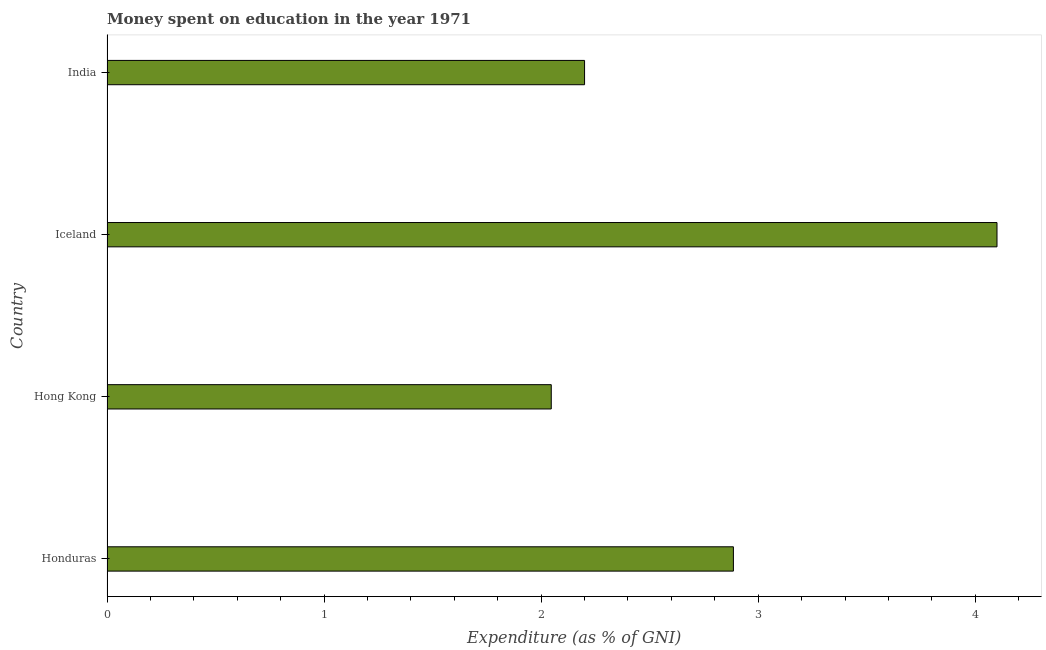What is the title of the graph?
Give a very brief answer. Money spent on education in the year 1971. What is the label or title of the X-axis?
Your answer should be very brief. Expenditure (as % of GNI). What is the label or title of the Y-axis?
Provide a succinct answer. Country. Across all countries, what is the maximum expenditure on education?
Keep it short and to the point. 4.1. Across all countries, what is the minimum expenditure on education?
Give a very brief answer. 2.05. In which country was the expenditure on education maximum?
Offer a very short reply. Iceland. In which country was the expenditure on education minimum?
Keep it short and to the point. Hong Kong. What is the sum of the expenditure on education?
Provide a succinct answer. 11.23. What is the difference between the expenditure on education in Honduras and Hong Kong?
Offer a very short reply. 0.84. What is the average expenditure on education per country?
Provide a succinct answer. 2.81. What is the median expenditure on education?
Provide a short and direct response. 2.54. What is the ratio of the expenditure on education in Hong Kong to that in India?
Offer a very short reply. 0.93. Is the expenditure on education in Hong Kong less than that in India?
Your answer should be very brief. Yes. Is the difference between the expenditure on education in Honduras and India greater than the difference between any two countries?
Your answer should be very brief. No. What is the difference between the highest and the second highest expenditure on education?
Provide a succinct answer. 1.21. Is the sum of the expenditure on education in Honduras and India greater than the maximum expenditure on education across all countries?
Provide a succinct answer. Yes. What is the difference between the highest and the lowest expenditure on education?
Provide a succinct answer. 2.05. How many countries are there in the graph?
Keep it short and to the point. 4. What is the Expenditure (as % of GNI) of Honduras?
Offer a terse response. 2.89. What is the Expenditure (as % of GNI) in Hong Kong?
Provide a short and direct response. 2.05. What is the Expenditure (as % of GNI) of Iceland?
Give a very brief answer. 4.1. What is the Expenditure (as % of GNI) in India?
Keep it short and to the point. 2.2. What is the difference between the Expenditure (as % of GNI) in Honduras and Hong Kong?
Offer a terse response. 0.84. What is the difference between the Expenditure (as % of GNI) in Honduras and Iceland?
Your answer should be very brief. -1.21. What is the difference between the Expenditure (as % of GNI) in Honduras and India?
Offer a terse response. 0.69. What is the difference between the Expenditure (as % of GNI) in Hong Kong and Iceland?
Make the answer very short. -2.05. What is the difference between the Expenditure (as % of GNI) in Hong Kong and India?
Ensure brevity in your answer.  -0.15. What is the difference between the Expenditure (as % of GNI) in Iceland and India?
Provide a short and direct response. 1.9. What is the ratio of the Expenditure (as % of GNI) in Honduras to that in Hong Kong?
Offer a very short reply. 1.41. What is the ratio of the Expenditure (as % of GNI) in Honduras to that in Iceland?
Make the answer very short. 0.7. What is the ratio of the Expenditure (as % of GNI) in Honduras to that in India?
Ensure brevity in your answer.  1.31. What is the ratio of the Expenditure (as % of GNI) in Hong Kong to that in Iceland?
Your answer should be very brief. 0.5. What is the ratio of the Expenditure (as % of GNI) in Hong Kong to that in India?
Give a very brief answer. 0.93. What is the ratio of the Expenditure (as % of GNI) in Iceland to that in India?
Offer a terse response. 1.86. 